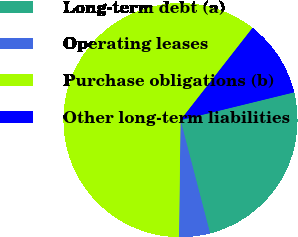Convert chart to OTSL. <chart><loc_0><loc_0><loc_500><loc_500><pie_chart><fcel>Long-term debt (a)<fcel>Operating leases<fcel>Purchase obligations (b)<fcel>Other long-term liabilities<nl><fcel>24.76%<fcel>4.27%<fcel>60.34%<fcel>10.62%<nl></chart> 